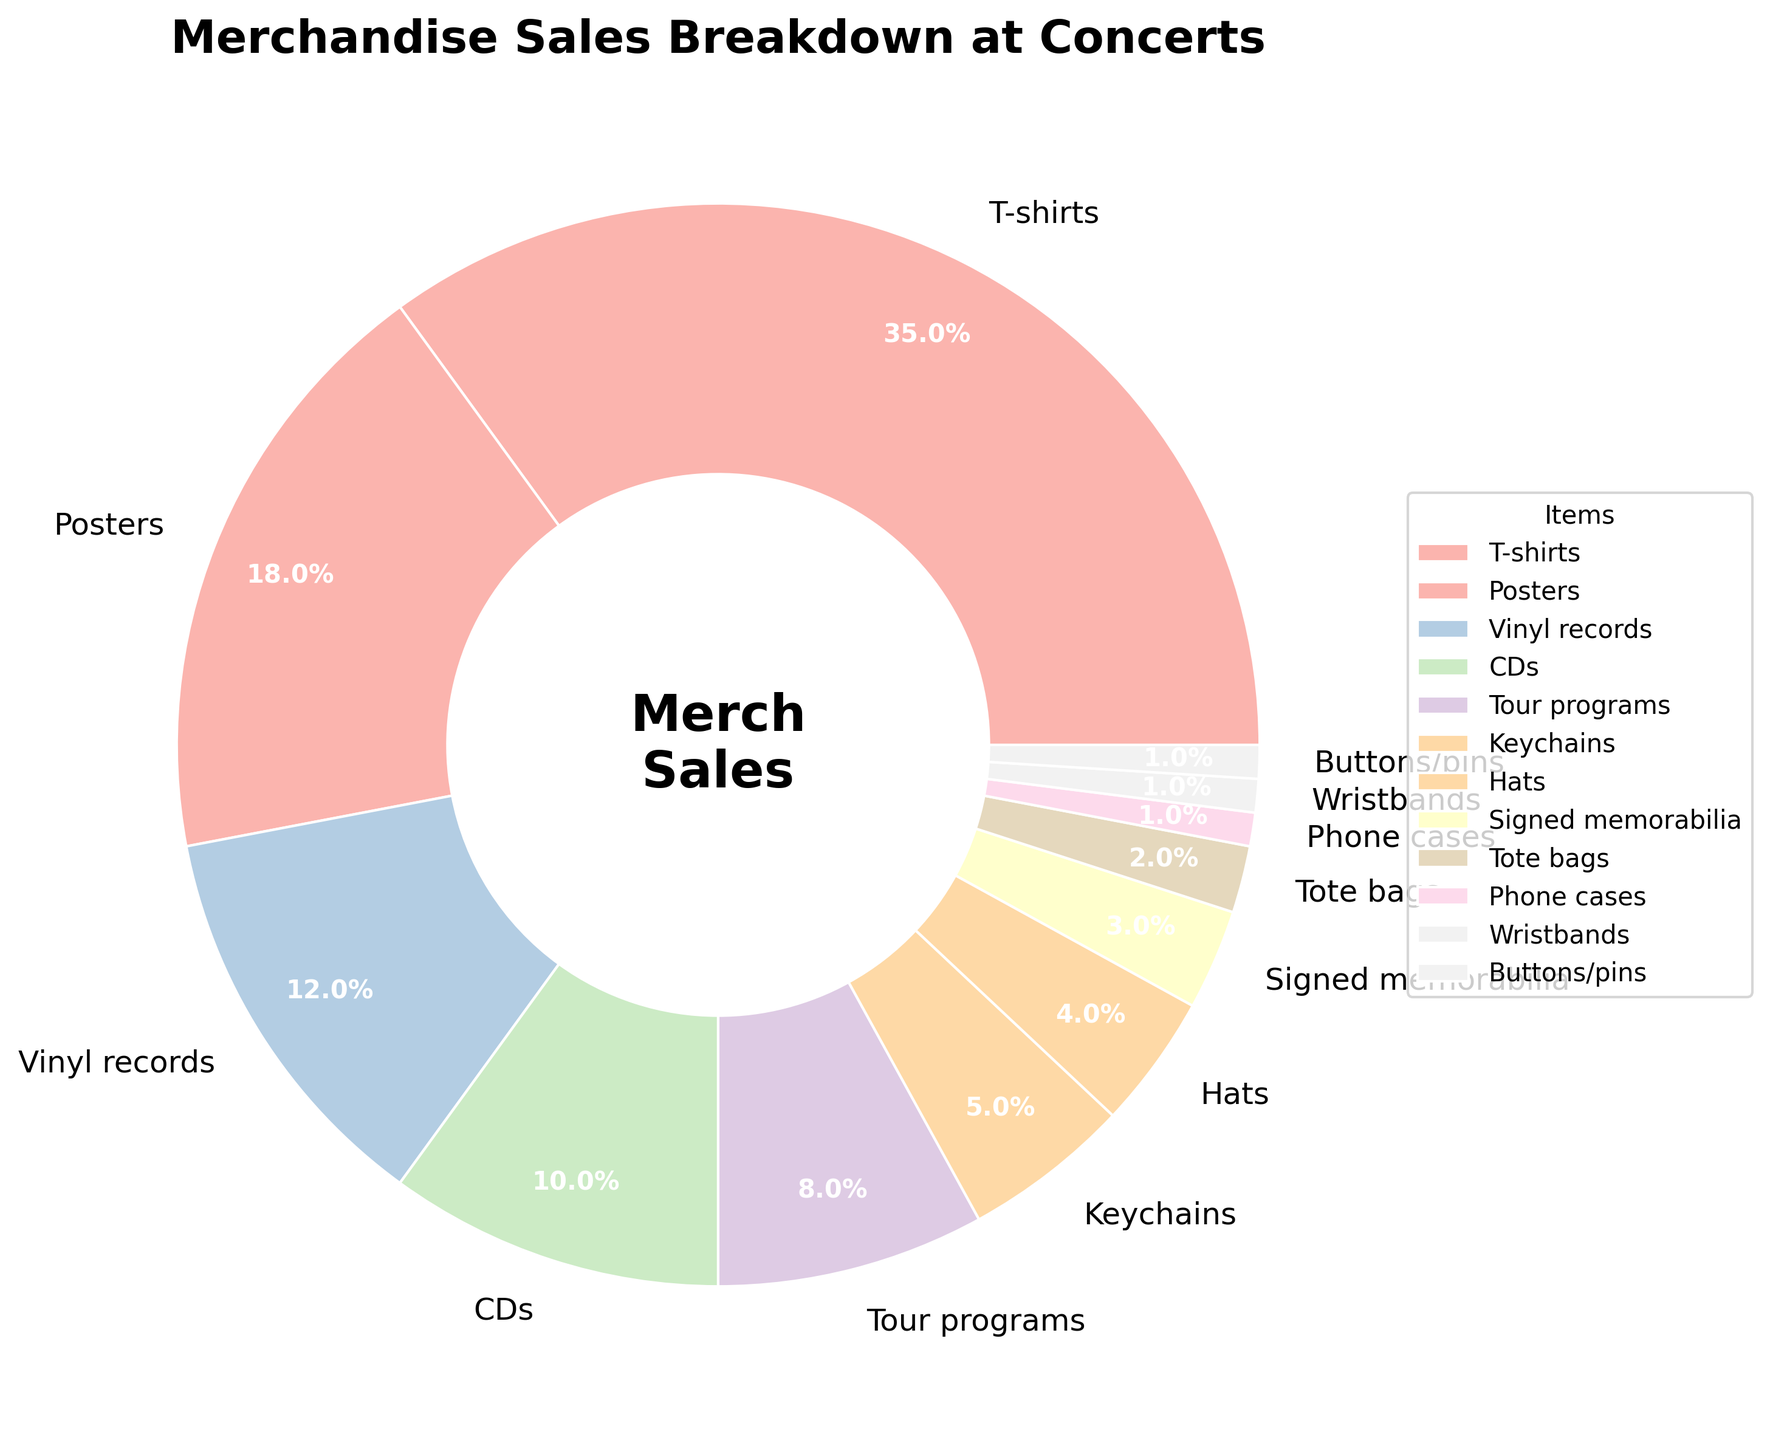Which item has the largest percentage of sales? The largest section in the pie chart is labeled "T-shirts," with the highest percentage value displayed.
Answer: T-shirts Which two items have the smallest percentages of sales combined? The smallest sections in the pie chart are labeled "Phone cases," "Wristbands," and "Buttons/pins," each with 1%. Combining them gives 1% + 1% + 1% = 3%, but we need two items, so selecting any two of these items will still give 2%.
Answer: Phone cases and Wristbands or Phone cases and Buttons/pins or Wristbands and Buttons/pins How much larger is the percentage of T-shirt sales compared to vinyl record sales? T-shirts have 35%, and vinyl records have 12%. The difference is calculated by subtracting the smaller percentage from the larger one: 35% - 12% = 23%.
Answer: 23% What is the combined percentage of sales for posters and CDs? Posters have 18%, and CDs have 10%. The combined percentage is given by adding these two values: 18% + 10% = 28%.
Answer: 28% Which item ranks fourth in terms of percentage of sales? The fourth-largest section in the pie chart corresponds to "CDs," following T-shirts, posters, and vinyl records.
Answer: CDs Which item has a percentage closest to 5%? "Keychains" has a percentage of 5% exactly, representing a single distinct section of the pie chart.
Answer: Keychains What's the total percentage of sales for all types of merchandise that make up less than 10% each? Items with less than 10% are Tour programs (8%), Keychains (5%), Hats (4%), Signed memorabilia (3%), Tote bags (2%), Phone cases (1%), Wristbands (1%), and Buttons/pins (1%). Summing these gives 8% + 5% + 4% + 3% + 2% + 1% + 1% + 1% = 25%.
Answer: 25% How does the percentage of hat sales compare to the combined percentage of phone cases, wristbands, and buttons/pins? Hat sales are 4%, and the combined percentage of phone cases, wristbands, and buttons/pins is 1% + 1% + 1% = 3%. Therefore, hat sales are 1% higher.
Answer: 1% higher What is the median percentage of sales among all the merchandise types? Arranging the percentages in ascending order: 1, 1, 1, 2, 3, 4, 5, 8, 10, 12, 18, 35. The middle two values in this list for 12 items are 4% and 5%. The median is the average of these two values: (4 + 5) / 2 = 4.5%.
Answer: 4.5% Which items have percentages that are exactly one-third or less than that of poster sales? Posters have 18%. One-third of 18% is 6%. Items with percentages less than or equal to 6% are Keychains (5%), Hats (4%), Signed memorabilia (3%), Tote bags (2%), Phone cases (1%), Wristbands (1%), and Buttons/pins (1%).
Answer: Keychains, Hats, Signed memorabilia, Tote bags, Phone cases, Wristbands, Buttons/pins 